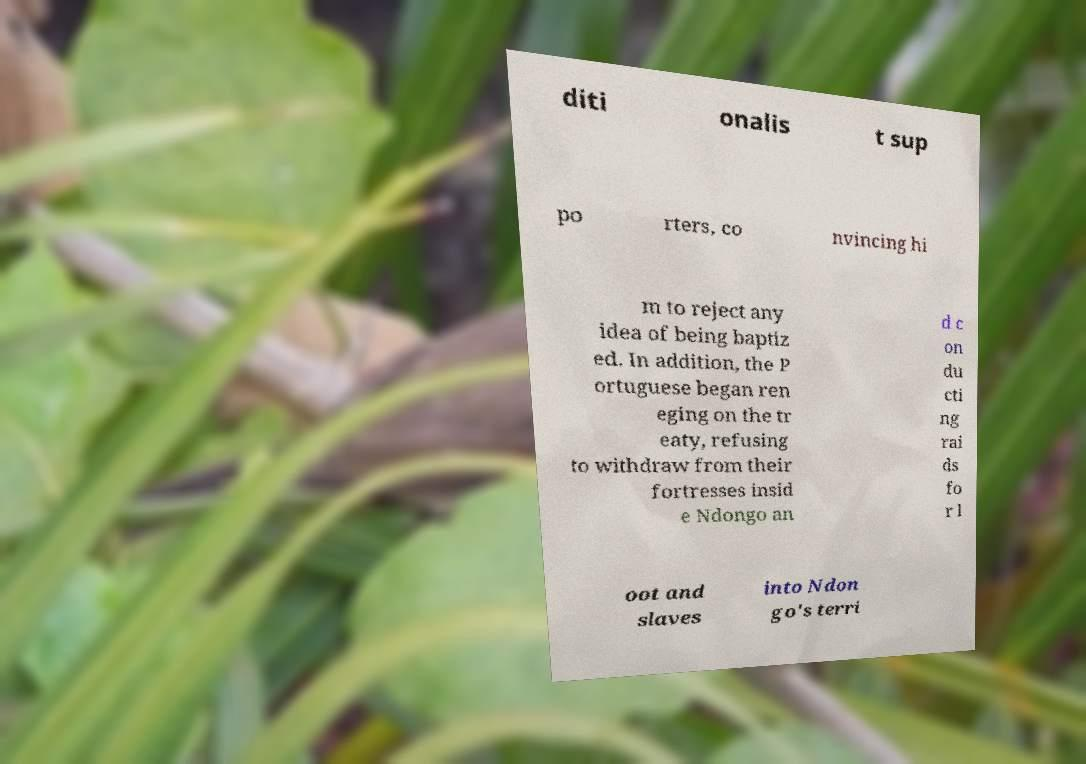There's text embedded in this image that I need extracted. Can you transcribe it verbatim? diti onalis t sup po rters, co nvincing hi m to reject any idea of being baptiz ed. In addition, the P ortuguese began ren eging on the tr eaty, refusing to withdraw from their fortresses insid e Ndongo an d c on du cti ng rai ds fo r l oot and slaves into Ndon go's terri 